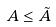Convert formula to latex. <formula><loc_0><loc_0><loc_500><loc_500>A \leq \tilde { A }</formula> 